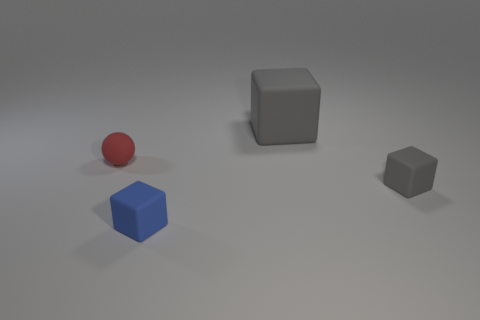How big is the thing that is both in front of the large thing and behind the small gray matte thing?
Make the answer very short. Small. Do the small cube that is in front of the tiny gray rubber cube and the sphere have the same color?
Ensure brevity in your answer.  No. What material is the object that is the same color as the big block?
Offer a terse response. Rubber. What number of things are the same color as the big matte block?
Give a very brief answer. 1. There is a gray rubber thing that is behind the red object; does it have the same shape as the blue rubber thing?
Offer a terse response. Yes. Is the number of matte spheres that are to the right of the rubber ball less than the number of small red matte balls that are to the left of the big rubber thing?
Offer a very short reply. Yes. There is a gray cube that is in front of the red rubber thing; what material is it?
Your answer should be compact. Rubber. What is the size of the matte object that is the same color as the big cube?
Keep it short and to the point. Small. Is there a blue metal sphere that has the same size as the red rubber ball?
Give a very brief answer. No. There is a blue rubber object; is its shape the same as the tiny matte object that is right of the blue rubber object?
Provide a short and direct response. Yes. 